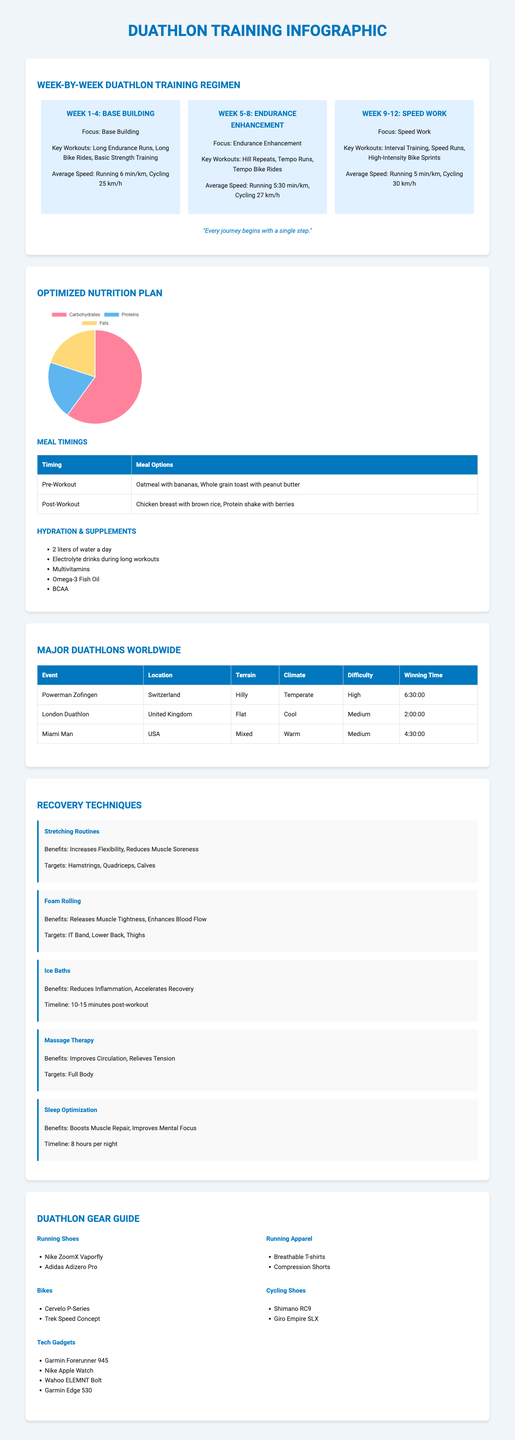What is the average speed for running in Week 1-4? The average speed for running during Week 1-4 is mentioned in the document as 6 min/km.
Answer: 6 min/km How many liters of water should be consumed daily according to the nutrition plan? The nutrition plan specifies that 2 liters of water should be consumed each day.
Answer: 2 liters What is the winning time of the London Duathlon? The document lists the winning time for the London Duathlon as 2:00:00.
Answer: 2:00:00 What are the key workouts in Week 9-12? The key workouts for Week 9-12 include interval training, speed runs, and high-intensity bike sprints.
Answer: Interval Training, Speed Runs, High-Intensity Bike Sprints Which recovery technique helps to improve circulation? The document states that massage therapy is the recovery technique that improves circulation.
Answer: Massage Therapy What is the macronutrient percentage for carbohydrates? The infographic states that carbohydrates make up 60% of the macronutrient breakdown.
Answer: 60% Which bike model is listed under essential gear? One of the bike models mentioned in the document is the Cervelo P-Series.
Answer: Cervelo P-Series What is the primary focus during Weeks 5-8? The focus during Weeks 5-8 is on endurance enhancement, as highlighted in the training regimen.
Answer: Endurance Enhancement 